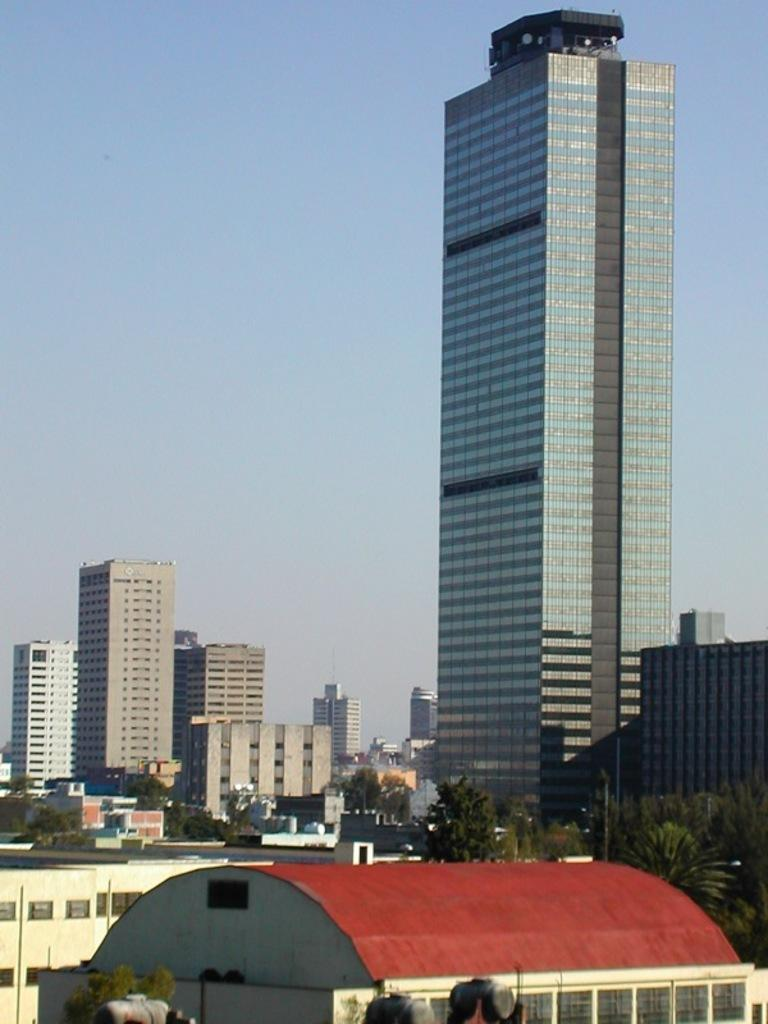What type of structures can be seen in the image? There are buildings in the image. What other natural elements are present in the image? There are trees in the image. Are there any man-made objects besides the buildings? Yes, there are poles in the image. What is visible at the top of the image? The sky is visible at the top of the image. Can you tell me how many yams are growing near the buildings in the image? There are no yams present in the image; it features buildings, trees, and poles. Is there any quicksand visible in the image? There is no quicksand present in the image. 